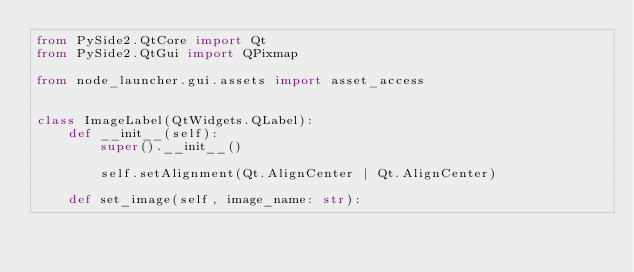Convert code to text. <code><loc_0><loc_0><loc_500><loc_500><_Python_>from PySide2.QtCore import Qt
from PySide2.QtGui import QPixmap

from node_launcher.gui.assets import asset_access


class ImageLabel(QtWidgets.QLabel):
    def __init__(self):
        super().__init__()

        self.setAlignment(Qt.AlignCenter | Qt.AlignCenter)

    def set_image(self, image_name: str):</code> 